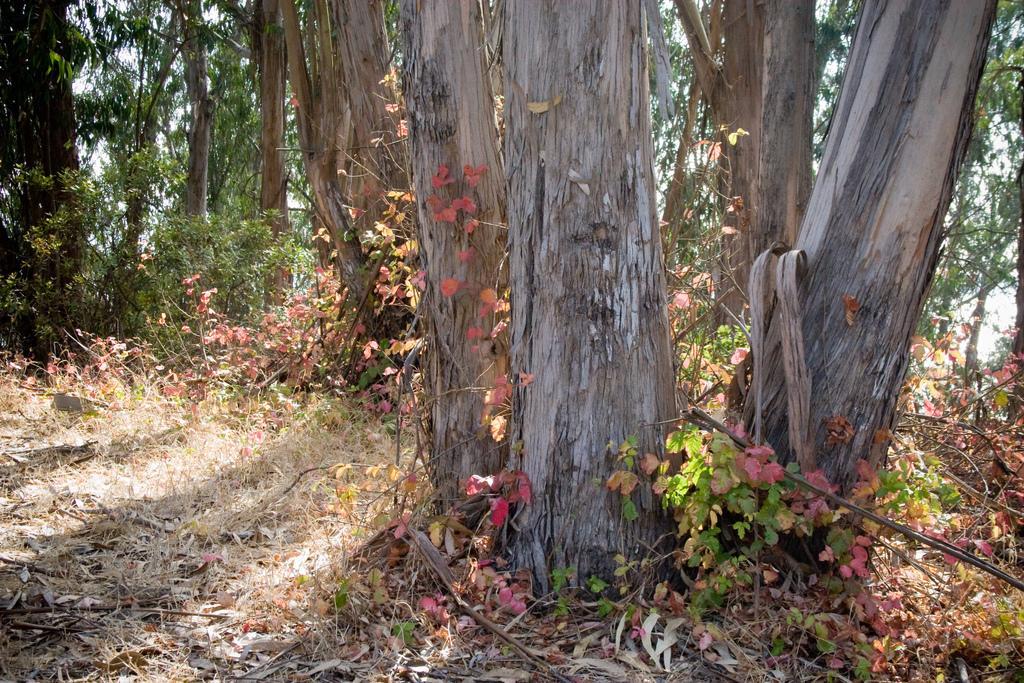How would you summarize this image in a sentence or two? Here in this picture we can see trees and plants present all over there on the ground. 